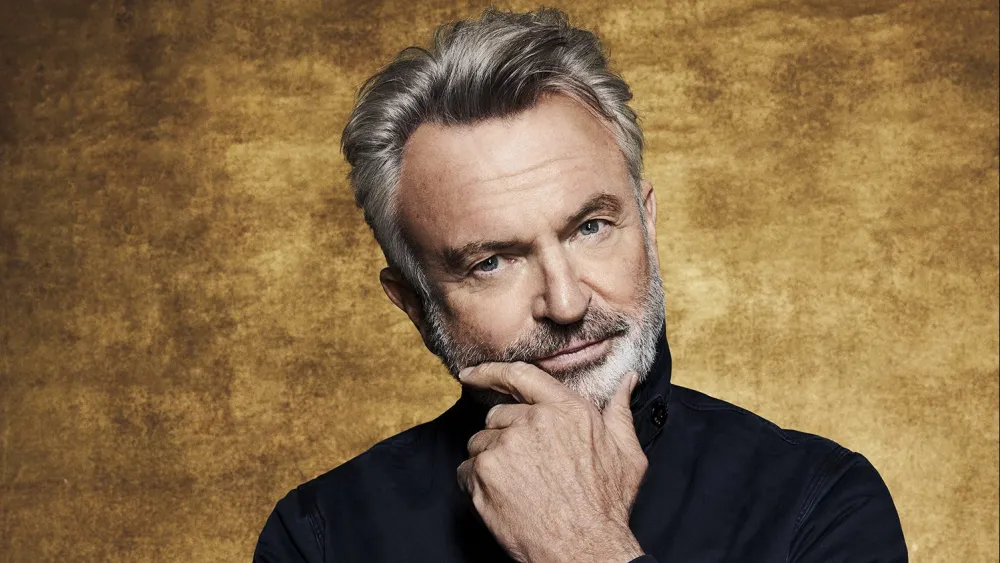What do you see happening in this image? The image portrays a person with a contemplative expression. They have their hand resting gently on their chin, a gesture often associated with deep thought. The individual is dressed in a dark shirt which conveys a classic and refined style. Additionally, a faint smile suggests a nuanced emotion, possibly reflecting inner amusement or contentment. The warm gold-hued background complements the individual's expression, lending an overall serene and thoughtful ambiance to the portrait. 